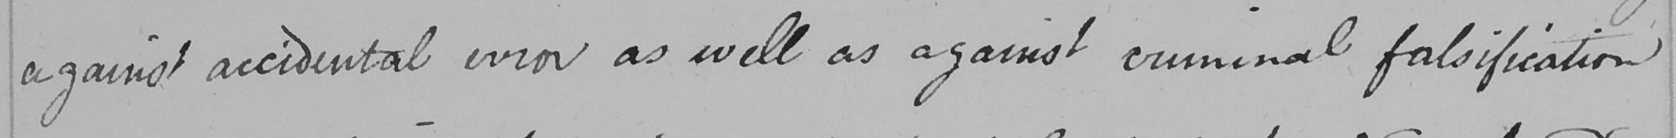What text is written in this handwritten line? against accidental error as well as against criminal falsification 